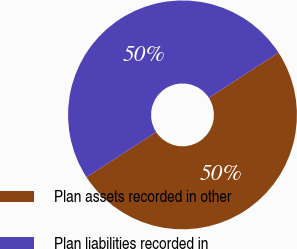Convert chart. <chart><loc_0><loc_0><loc_500><loc_500><pie_chart><fcel>Plan assets recorded in other<fcel>Plan liabilities recorded in<nl><fcel>50.0%<fcel>50.0%<nl></chart> 